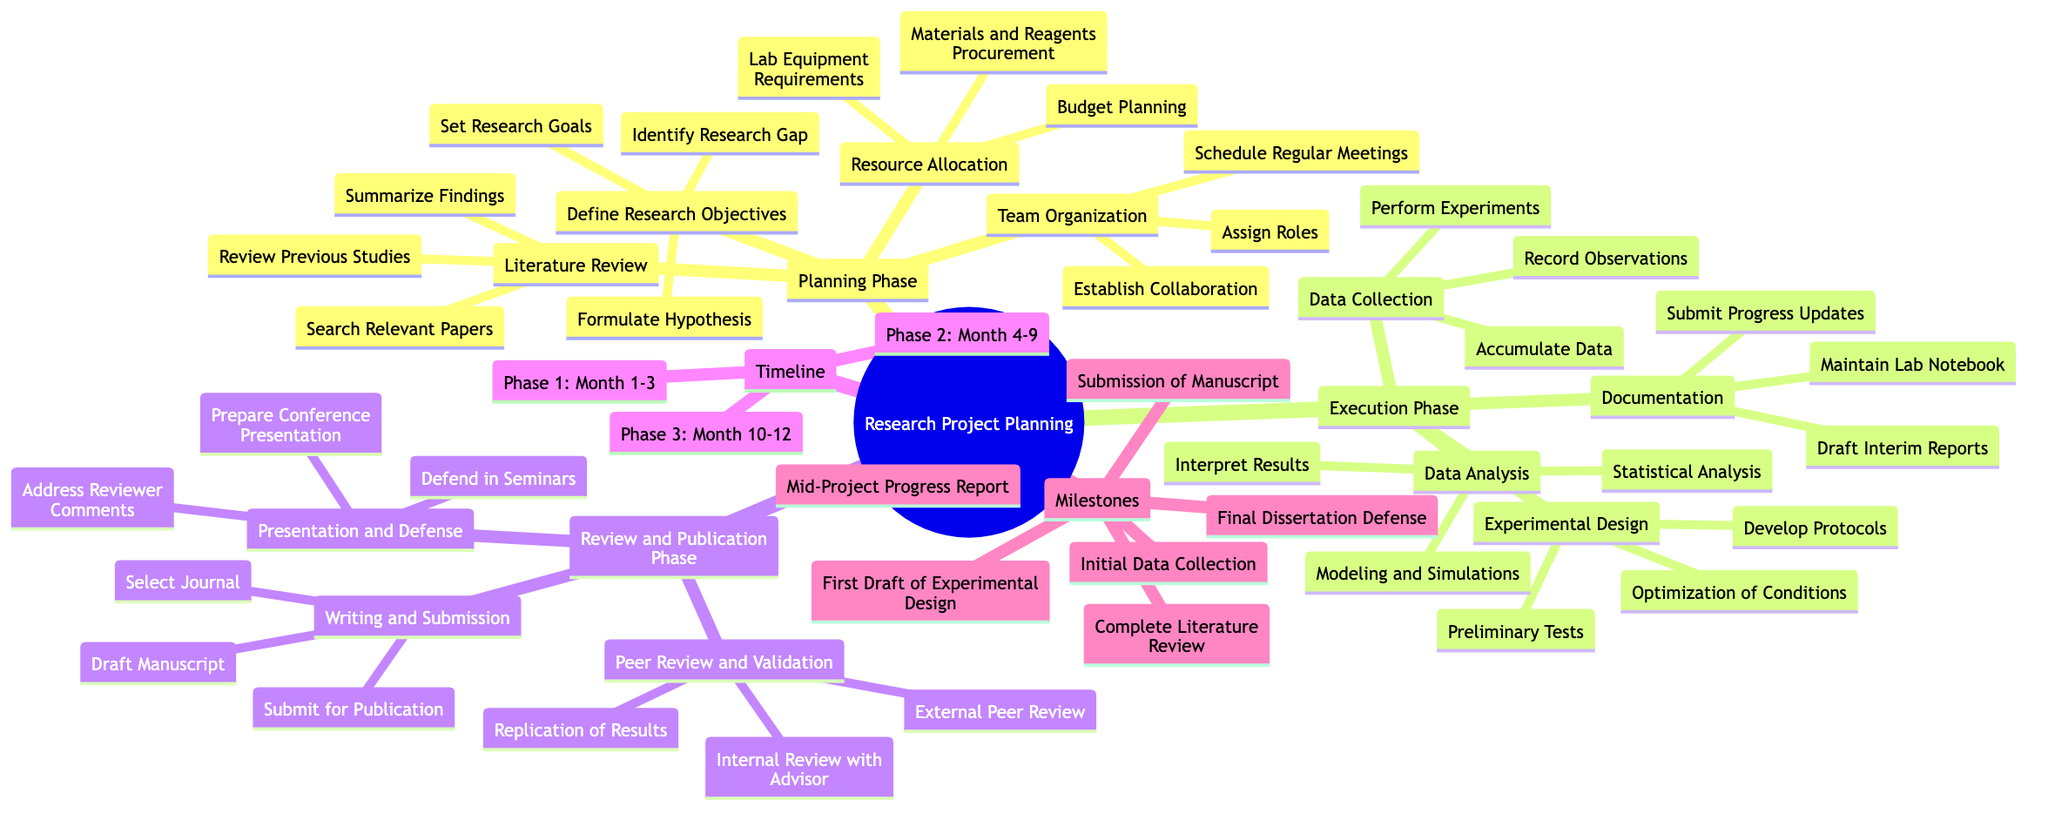What are the three phases of the research project planning? The diagram clearly outlines the major phases of the research project planning as branches stemming from the root. The first three branches labeled are "Planning Phase," "Execution Phase," and "Review and Publication Phase."
Answer: Planning Phase, Execution Phase, Review and Publication Phase How many tasks are included in the "Resource Allocation" section? By exploring the "Resource Allocation" branch under the "Planning Phase," we find that it consists of three specific tasks: "Budget Planning," "Lab Equipment Requirements," and "Materials and Reagents Procurement."
Answer: 3 What is the timeline for Phase 2? Checking the "Timeline" section of the diagram, we observe that Phase 2 is explicitly labeled with the duration from "Month 4" to "Month 9."
Answer: Month 4-9 Which task is associated with the "Data Analysis" section? The "Data Analysis" section under "Execution Phase" contains three tasks: "Statistical Analysis," "Modeling and Simulations," and "Interpret Results." Therefore, any of these tasks can be considered an answer.
Answer: Statistical Analysis (or Modeling and Simulations, or Interpret Results) What is the first milestone listed in the milestones section? In the "Milestones" section, the first item listed is "Complete Literature Review." This indicates it is the first milestone to be achieved in the project timeline.
Answer: Complete Literature Review Which team task falls under the "Team Organization" category? Looking at the "Team Organization" section, we can identify three specific tasks: "Assign Roles," "Establish Collaboration," and "Schedule Regular Meetings." Therefore, any one of these would qualify as an answer.
Answer: Assign Roles (or Establish Collaboration, or Schedule Regular Meetings) What is the last task in the "Presentation and Defense" section? In the "Presentation and Defense" category, the tasks are organized sequentially, with "Address Reviewer Comments" as the last one listed. Thus, it is the final task to be completed in this section.
Answer: Address Reviewer Comments How many tasks are listed under the "Documentation" section? The "Documentation" section contains three distinct tasks: "Maintain Lab Notebook," "Draft Interim Reports," and "Submit Progress Updates." Therefore, there are a total of three tasks listed here.
Answer: 3 